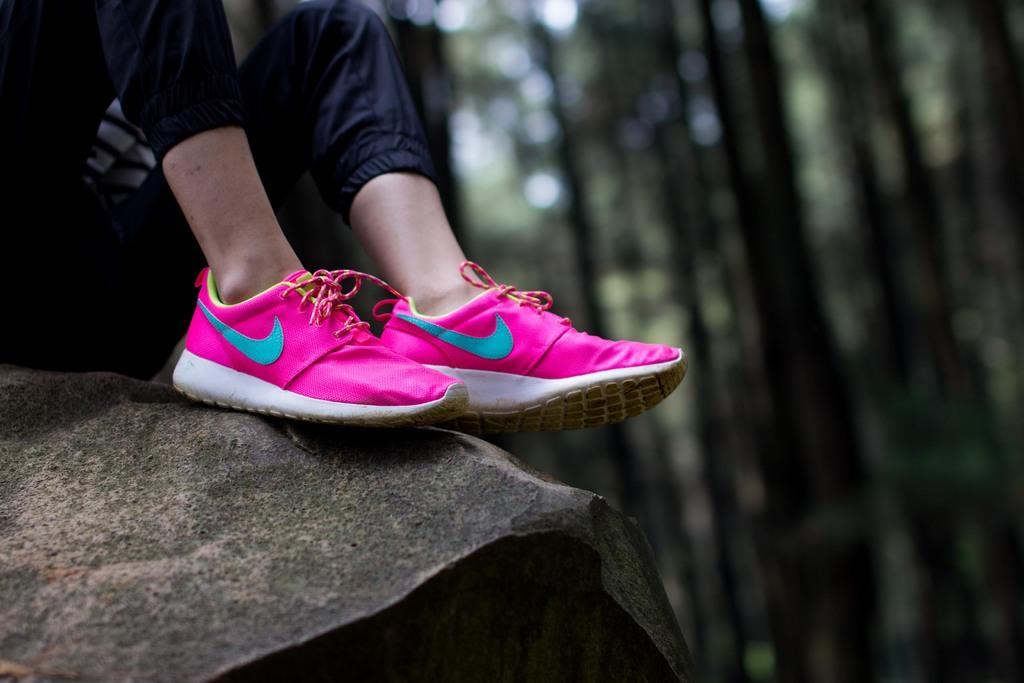In one or two sentences, can you explain what this image depicts? In this picture there is a person wearing pink color shoes placed it on a rock and there are few trees in the background. 